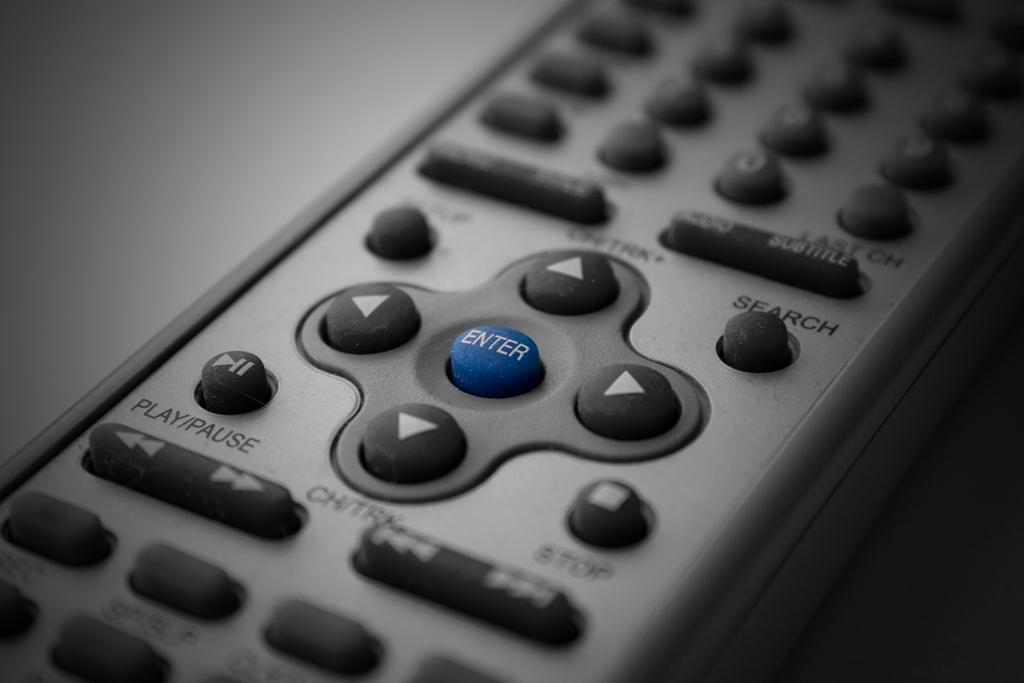<image>
Provide a brief description of the given image. A grey and black remote control that has a play/pause button. 